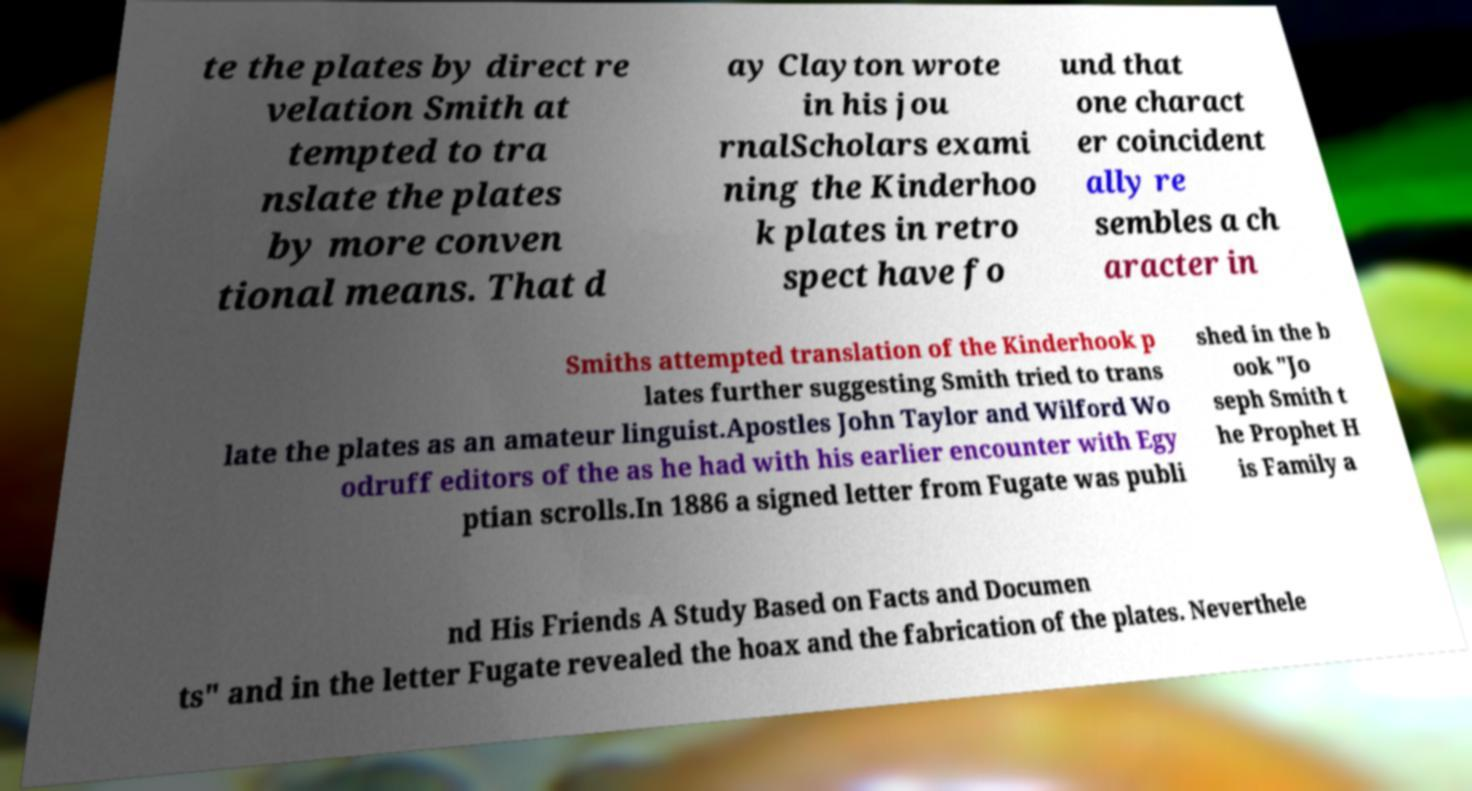I need the written content from this picture converted into text. Can you do that? te the plates by direct re velation Smith at tempted to tra nslate the plates by more conven tional means. That d ay Clayton wrote in his jou rnalScholars exami ning the Kinderhoo k plates in retro spect have fo und that one charact er coincident ally re sembles a ch aracter in Smiths attempted translation of the Kinderhook p lates further suggesting Smith tried to trans late the plates as an amateur linguist.Apostles John Taylor and Wilford Wo odruff editors of the as he had with his earlier encounter with Egy ptian scrolls.In 1886 a signed letter from Fugate was publi shed in the b ook "Jo seph Smith t he Prophet H is Family a nd His Friends A Study Based on Facts and Documen ts" and in the letter Fugate revealed the hoax and the fabrication of the plates. Neverthele 